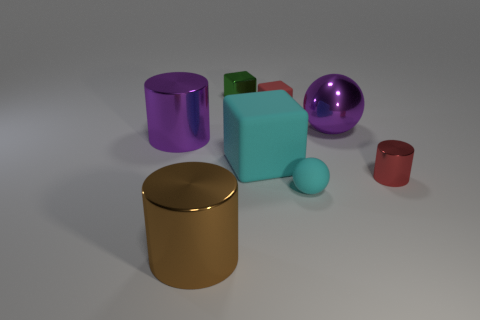The tiny matte sphere has what color? cyan 